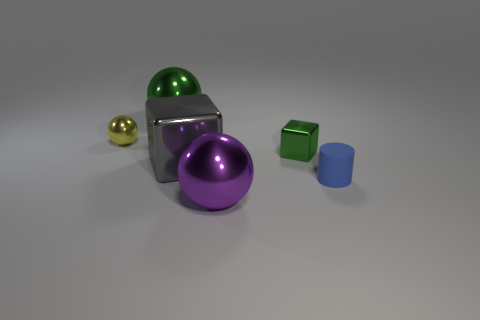There is a large sphere that is behind the small blue rubber thing; is it the same color as the tiny metallic object that is on the right side of the large purple shiny sphere?
Provide a short and direct response. Yes. Are there any purple metallic spheres in front of the purple ball?
Ensure brevity in your answer.  No. What is the tiny green cube made of?
Your response must be concise. Metal. There is a big metal object in front of the small blue thing; what is its shape?
Offer a terse response. Sphere. What size is the thing that is the same color as the tiny block?
Provide a short and direct response. Large. Are there any gray cubes that have the same size as the purple shiny object?
Give a very brief answer. Yes. Is the material of the green object to the right of the gray object the same as the tiny yellow sphere?
Ensure brevity in your answer.  Yes. Is the number of big gray metallic cubes that are in front of the large gray metallic block the same as the number of purple shiny balls that are right of the small metal ball?
Ensure brevity in your answer.  No. The thing that is behind the tiny green metal object and right of the yellow metal thing has what shape?
Offer a terse response. Sphere. What number of tiny metallic objects are left of the large gray metal block?
Your answer should be very brief. 1. 